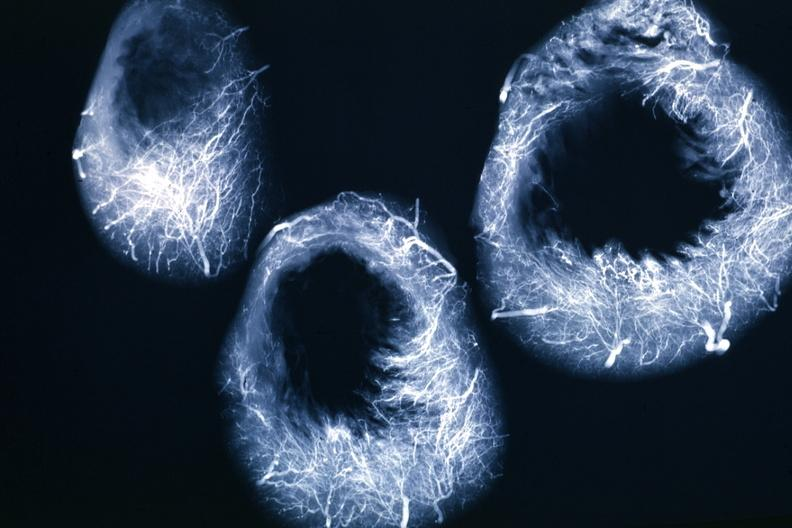what does this image show?
Answer the question using a single word or phrase. X-ray horizontal sections of ventricle showing penetrating artery distribution quite good 